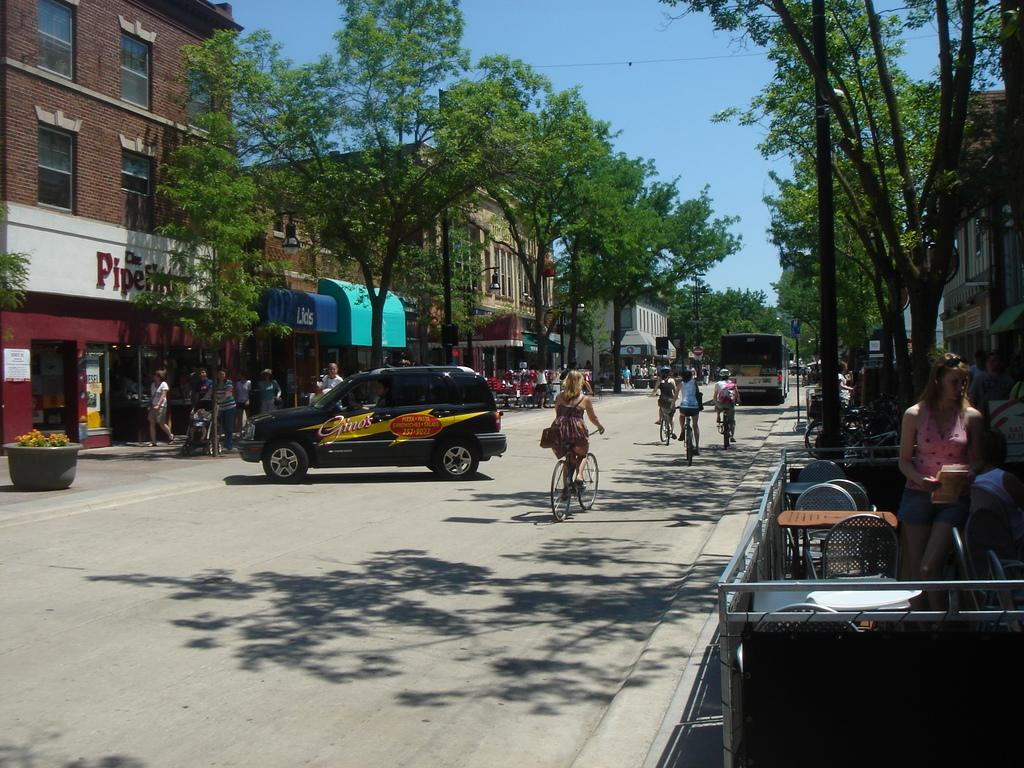Provide a one-sentence caption for the provided image. Gino's pizza, pasta, sandwiches, and salad logo on a jeep. 